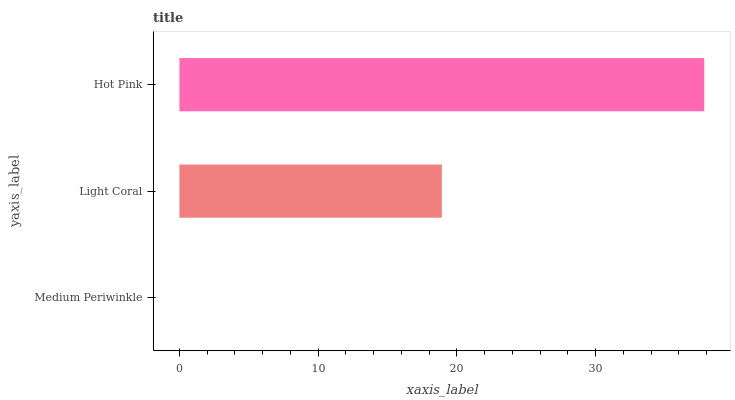Is Medium Periwinkle the minimum?
Answer yes or no. Yes. Is Hot Pink the maximum?
Answer yes or no. Yes. Is Light Coral the minimum?
Answer yes or no. No. Is Light Coral the maximum?
Answer yes or no. No. Is Light Coral greater than Medium Periwinkle?
Answer yes or no. Yes. Is Medium Periwinkle less than Light Coral?
Answer yes or no. Yes. Is Medium Periwinkle greater than Light Coral?
Answer yes or no. No. Is Light Coral less than Medium Periwinkle?
Answer yes or no. No. Is Light Coral the high median?
Answer yes or no. Yes. Is Light Coral the low median?
Answer yes or no. Yes. Is Medium Periwinkle the high median?
Answer yes or no. No. Is Hot Pink the low median?
Answer yes or no. No. 